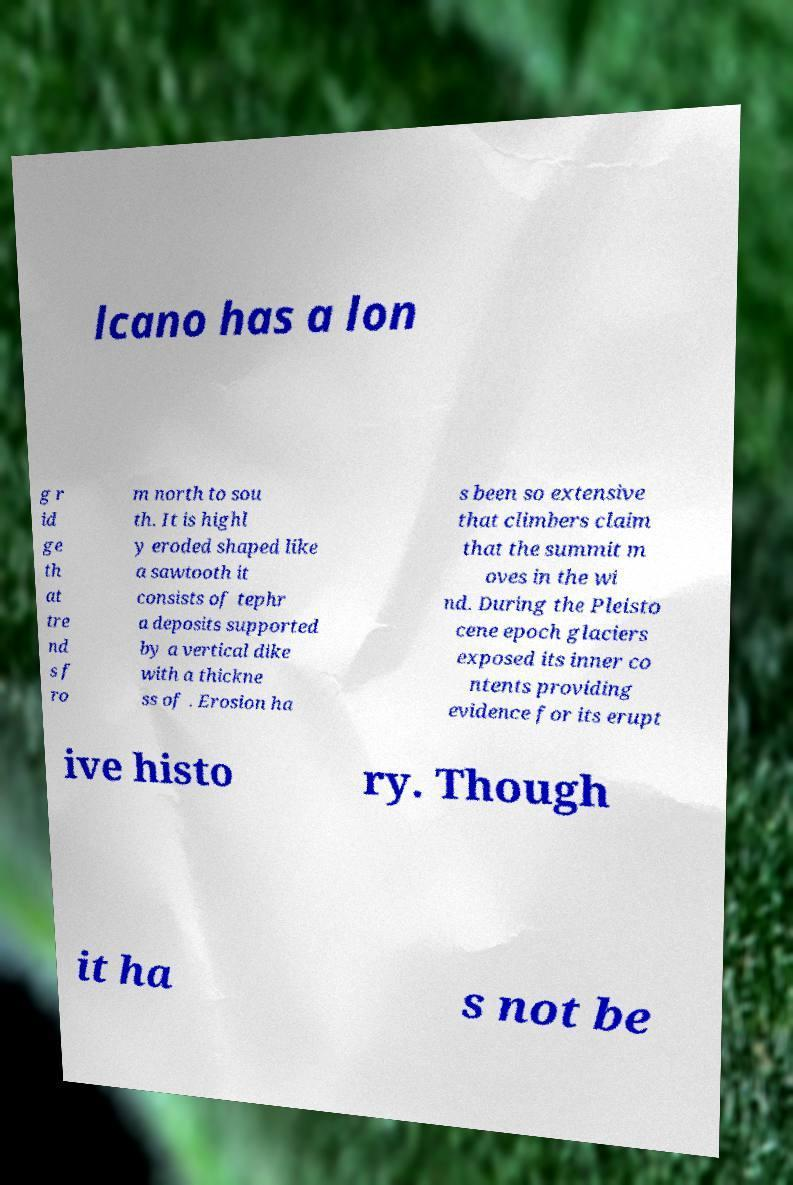There's text embedded in this image that I need extracted. Can you transcribe it verbatim? lcano has a lon g r id ge th at tre nd s f ro m north to sou th. It is highl y eroded shaped like a sawtooth it consists of tephr a deposits supported by a vertical dike with a thickne ss of . Erosion ha s been so extensive that climbers claim that the summit m oves in the wi nd. During the Pleisto cene epoch glaciers exposed its inner co ntents providing evidence for its erupt ive histo ry. Though it ha s not be 